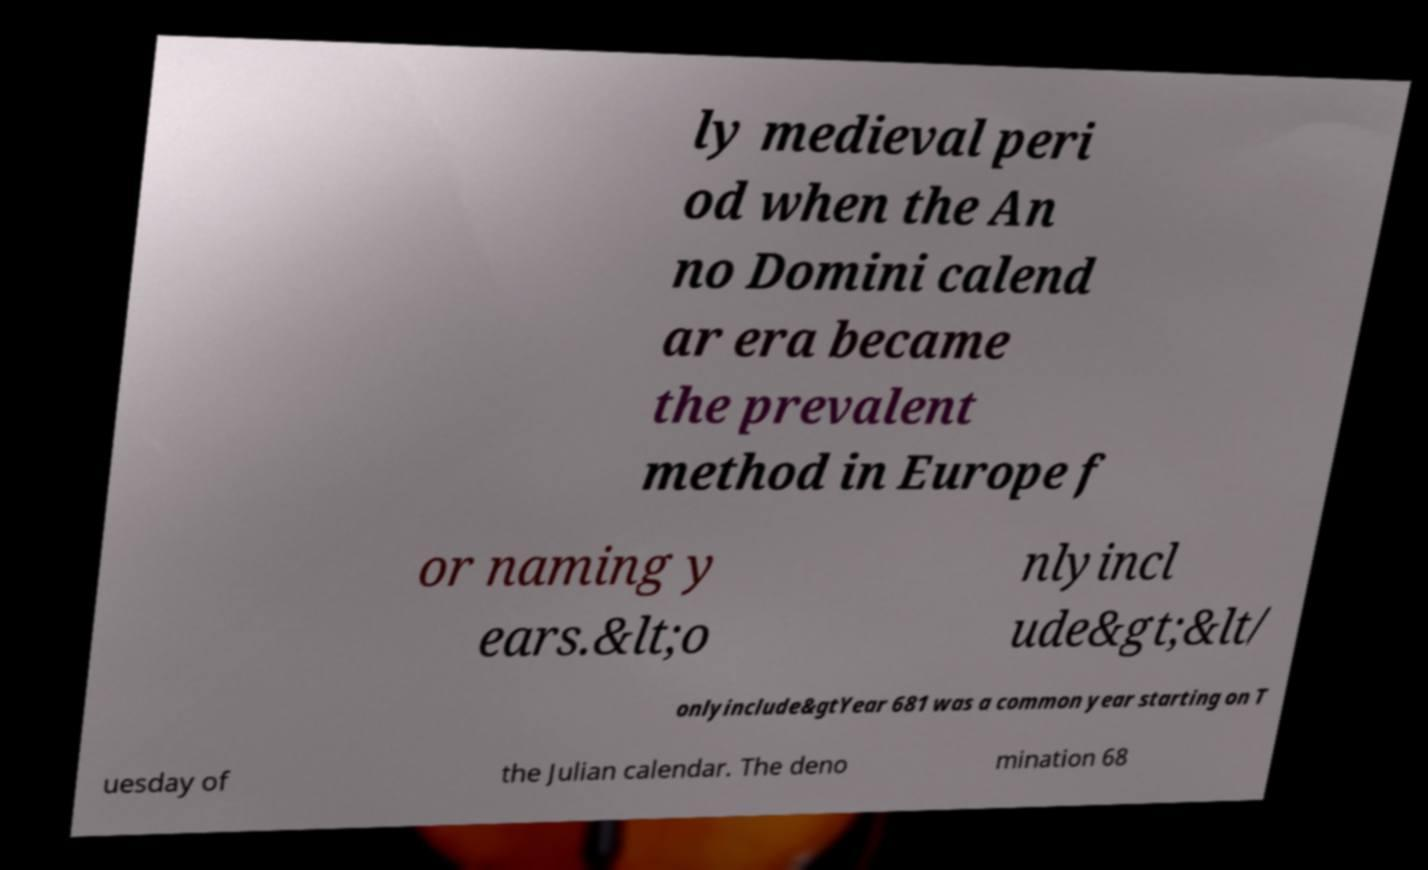There's text embedded in this image that I need extracted. Can you transcribe it verbatim? ly medieval peri od when the An no Domini calend ar era became the prevalent method in Europe f or naming y ears.&lt;o nlyincl ude&gt;&lt/ onlyinclude&gtYear 681 was a common year starting on T uesday of the Julian calendar. The deno mination 68 